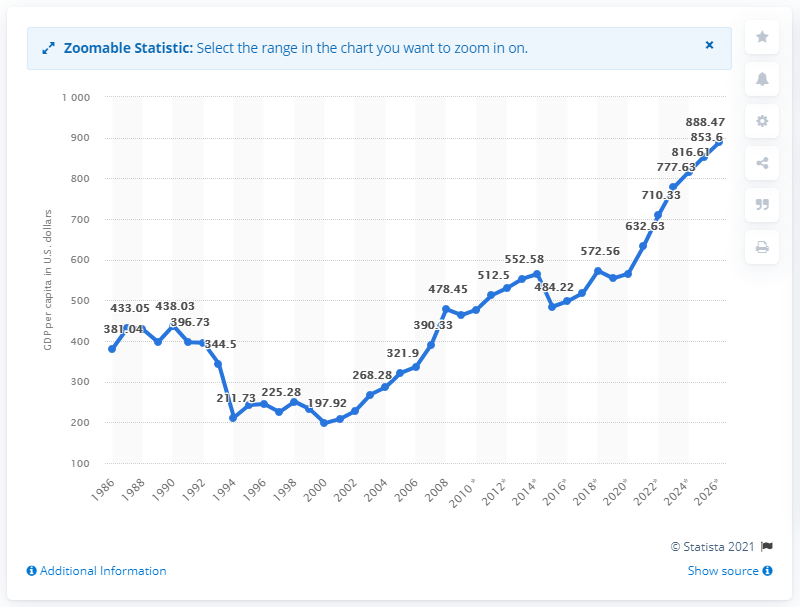Mention a couple of crucial points in this snapshot. In 2019, the Gross Domestic Product (GDP) per capita in Niger was 553.91. 